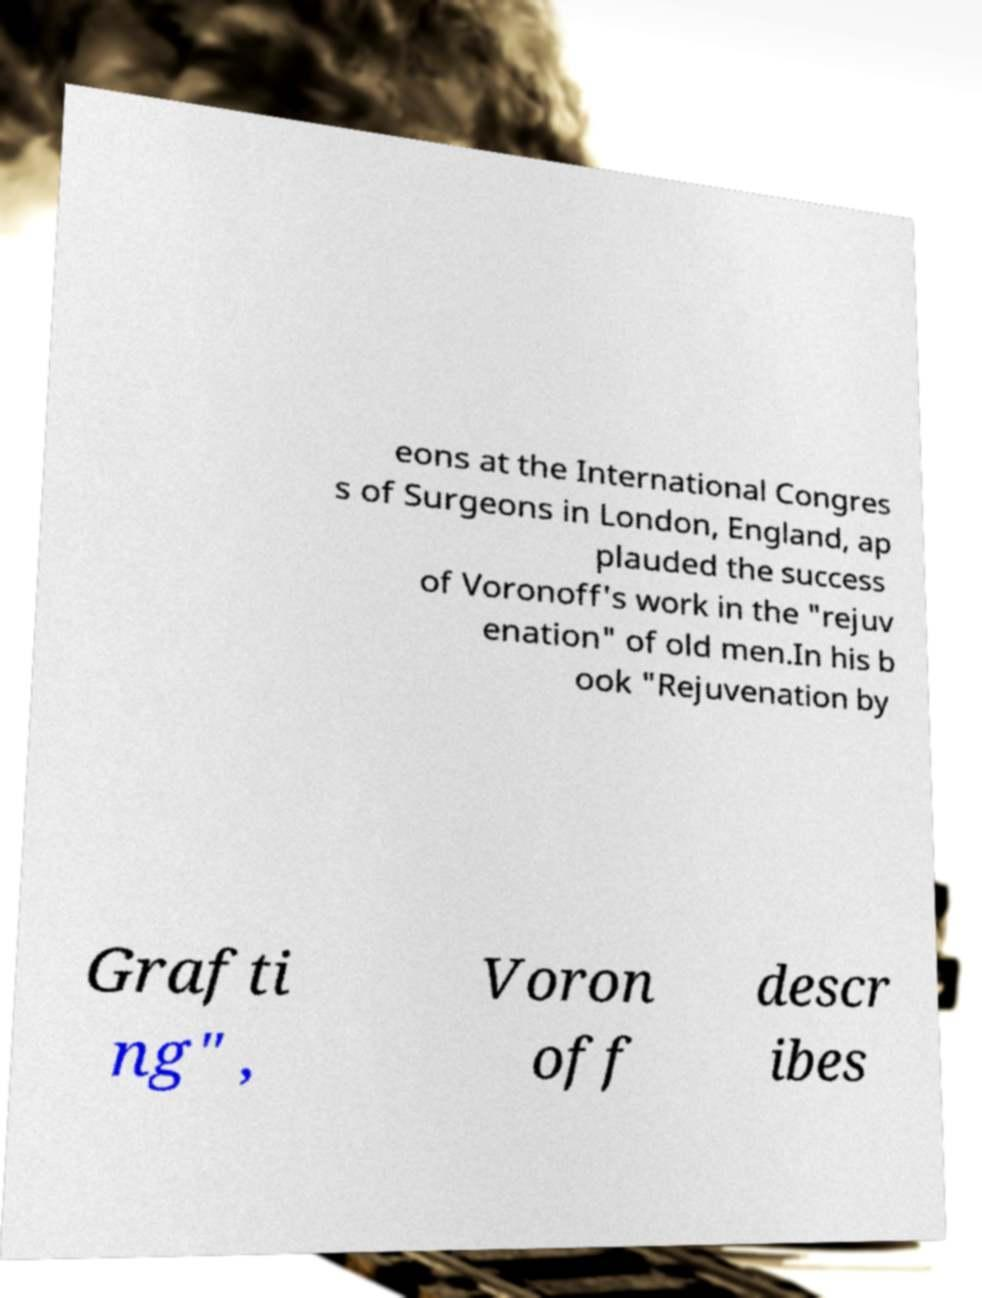Please identify and transcribe the text found in this image. eons at the International Congres s of Surgeons in London, England, ap plauded the success of Voronoff's work in the "rejuv enation" of old men.In his b ook "Rejuvenation by Grafti ng" , Voron off descr ibes 